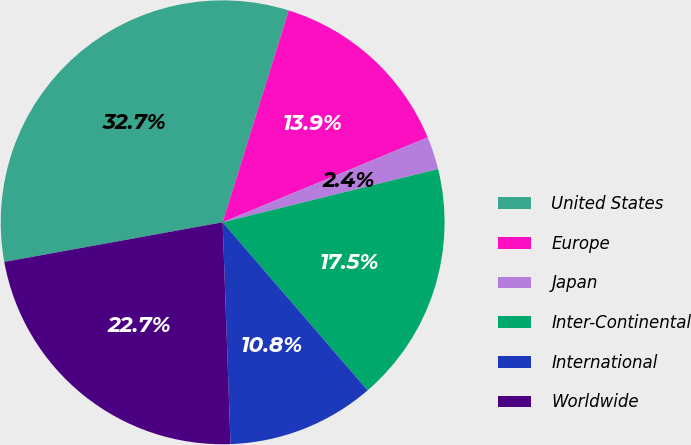Convert chart. <chart><loc_0><loc_0><loc_500><loc_500><pie_chart><fcel>United States<fcel>Europe<fcel>Japan<fcel>Inter-Continental<fcel>International<fcel>Worldwide<nl><fcel>32.67%<fcel>13.94%<fcel>2.39%<fcel>17.53%<fcel>10.76%<fcel>22.71%<nl></chart> 